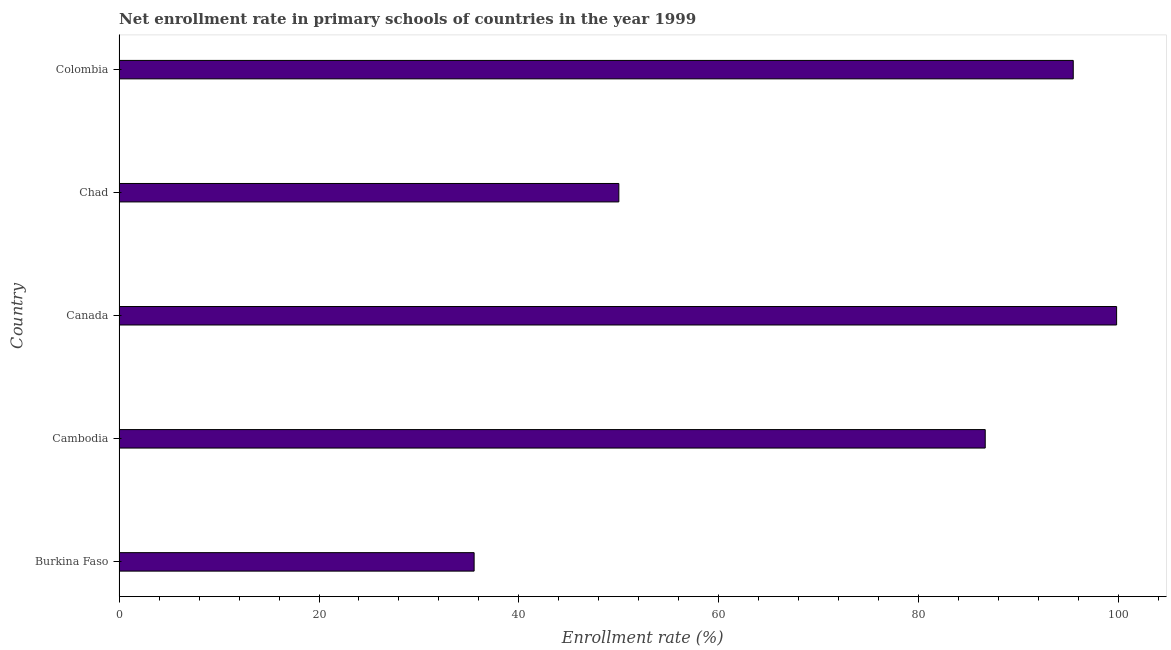Does the graph contain any zero values?
Keep it short and to the point. No. What is the title of the graph?
Ensure brevity in your answer.  Net enrollment rate in primary schools of countries in the year 1999. What is the label or title of the X-axis?
Give a very brief answer. Enrollment rate (%). What is the label or title of the Y-axis?
Your answer should be compact. Country. What is the net enrollment rate in primary schools in Burkina Faso?
Give a very brief answer. 35.52. Across all countries, what is the maximum net enrollment rate in primary schools?
Give a very brief answer. 99.78. Across all countries, what is the minimum net enrollment rate in primary schools?
Ensure brevity in your answer.  35.52. In which country was the net enrollment rate in primary schools maximum?
Make the answer very short. Canada. In which country was the net enrollment rate in primary schools minimum?
Provide a succinct answer. Burkina Faso. What is the sum of the net enrollment rate in primary schools?
Your response must be concise. 367.38. What is the difference between the net enrollment rate in primary schools in Cambodia and Colombia?
Offer a very short reply. -8.8. What is the average net enrollment rate in primary schools per country?
Your answer should be very brief. 73.48. What is the median net enrollment rate in primary schools?
Your answer should be compact. 86.64. In how many countries, is the net enrollment rate in primary schools greater than 8 %?
Keep it short and to the point. 5. What is the ratio of the net enrollment rate in primary schools in Burkina Faso to that in Cambodia?
Offer a very short reply. 0.41. Is the net enrollment rate in primary schools in Canada less than that in Chad?
Provide a succinct answer. No. Is the difference between the net enrollment rate in primary schools in Cambodia and Colombia greater than the difference between any two countries?
Offer a very short reply. No. What is the difference between the highest and the second highest net enrollment rate in primary schools?
Provide a succinct answer. 4.34. What is the difference between the highest and the lowest net enrollment rate in primary schools?
Provide a short and direct response. 64.27. In how many countries, is the net enrollment rate in primary schools greater than the average net enrollment rate in primary schools taken over all countries?
Provide a succinct answer. 3. How many bars are there?
Your answer should be very brief. 5. Are all the bars in the graph horizontal?
Keep it short and to the point. Yes. What is the Enrollment rate (%) of Burkina Faso?
Your answer should be very brief. 35.52. What is the Enrollment rate (%) of Cambodia?
Your response must be concise. 86.64. What is the Enrollment rate (%) in Canada?
Your answer should be compact. 99.78. What is the Enrollment rate (%) of Chad?
Provide a succinct answer. 49.99. What is the Enrollment rate (%) of Colombia?
Give a very brief answer. 95.45. What is the difference between the Enrollment rate (%) in Burkina Faso and Cambodia?
Your answer should be compact. -51.13. What is the difference between the Enrollment rate (%) in Burkina Faso and Canada?
Provide a short and direct response. -64.27. What is the difference between the Enrollment rate (%) in Burkina Faso and Chad?
Ensure brevity in your answer.  -14.48. What is the difference between the Enrollment rate (%) in Burkina Faso and Colombia?
Your answer should be compact. -59.93. What is the difference between the Enrollment rate (%) in Cambodia and Canada?
Offer a terse response. -13.14. What is the difference between the Enrollment rate (%) in Cambodia and Chad?
Ensure brevity in your answer.  36.65. What is the difference between the Enrollment rate (%) in Cambodia and Colombia?
Offer a terse response. -8.8. What is the difference between the Enrollment rate (%) in Canada and Chad?
Your response must be concise. 49.79. What is the difference between the Enrollment rate (%) in Canada and Colombia?
Your answer should be very brief. 4.34. What is the difference between the Enrollment rate (%) in Chad and Colombia?
Your answer should be compact. -45.45. What is the ratio of the Enrollment rate (%) in Burkina Faso to that in Cambodia?
Offer a terse response. 0.41. What is the ratio of the Enrollment rate (%) in Burkina Faso to that in Canada?
Give a very brief answer. 0.36. What is the ratio of the Enrollment rate (%) in Burkina Faso to that in Chad?
Keep it short and to the point. 0.71. What is the ratio of the Enrollment rate (%) in Burkina Faso to that in Colombia?
Ensure brevity in your answer.  0.37. What is the ratio of the Enrollment rate (%) in Cambodia to that in Canada?
Give a very brief answer. 0.87. What is the ratio of the Enrollment rate (%) in Cambodia to that in Chad?
Keep it short and to the point. 1.73. What is the ratio of the Enrollment rate (%) in Cambodia to that in Colombia?
Provide a short and direct response. 0.91. What is the ratio of the Enrollment rate (%) in Canada to that in Chad?
Keep it short and to the point. 2. What is the ratio of the Enrollment rate (%) in Canada to that in Colombia?
Keep it short and to the point. 1.04. What is the ratio of the Enrollment rate (%) in Chad to that in Colombia?
Offer a terse response. 0.52. 